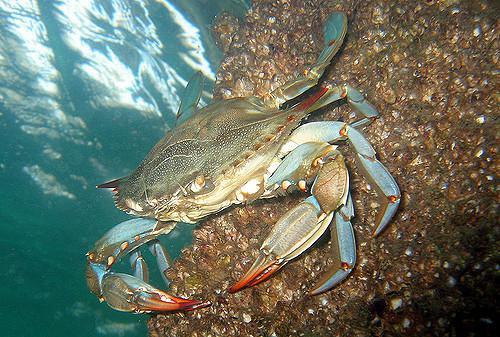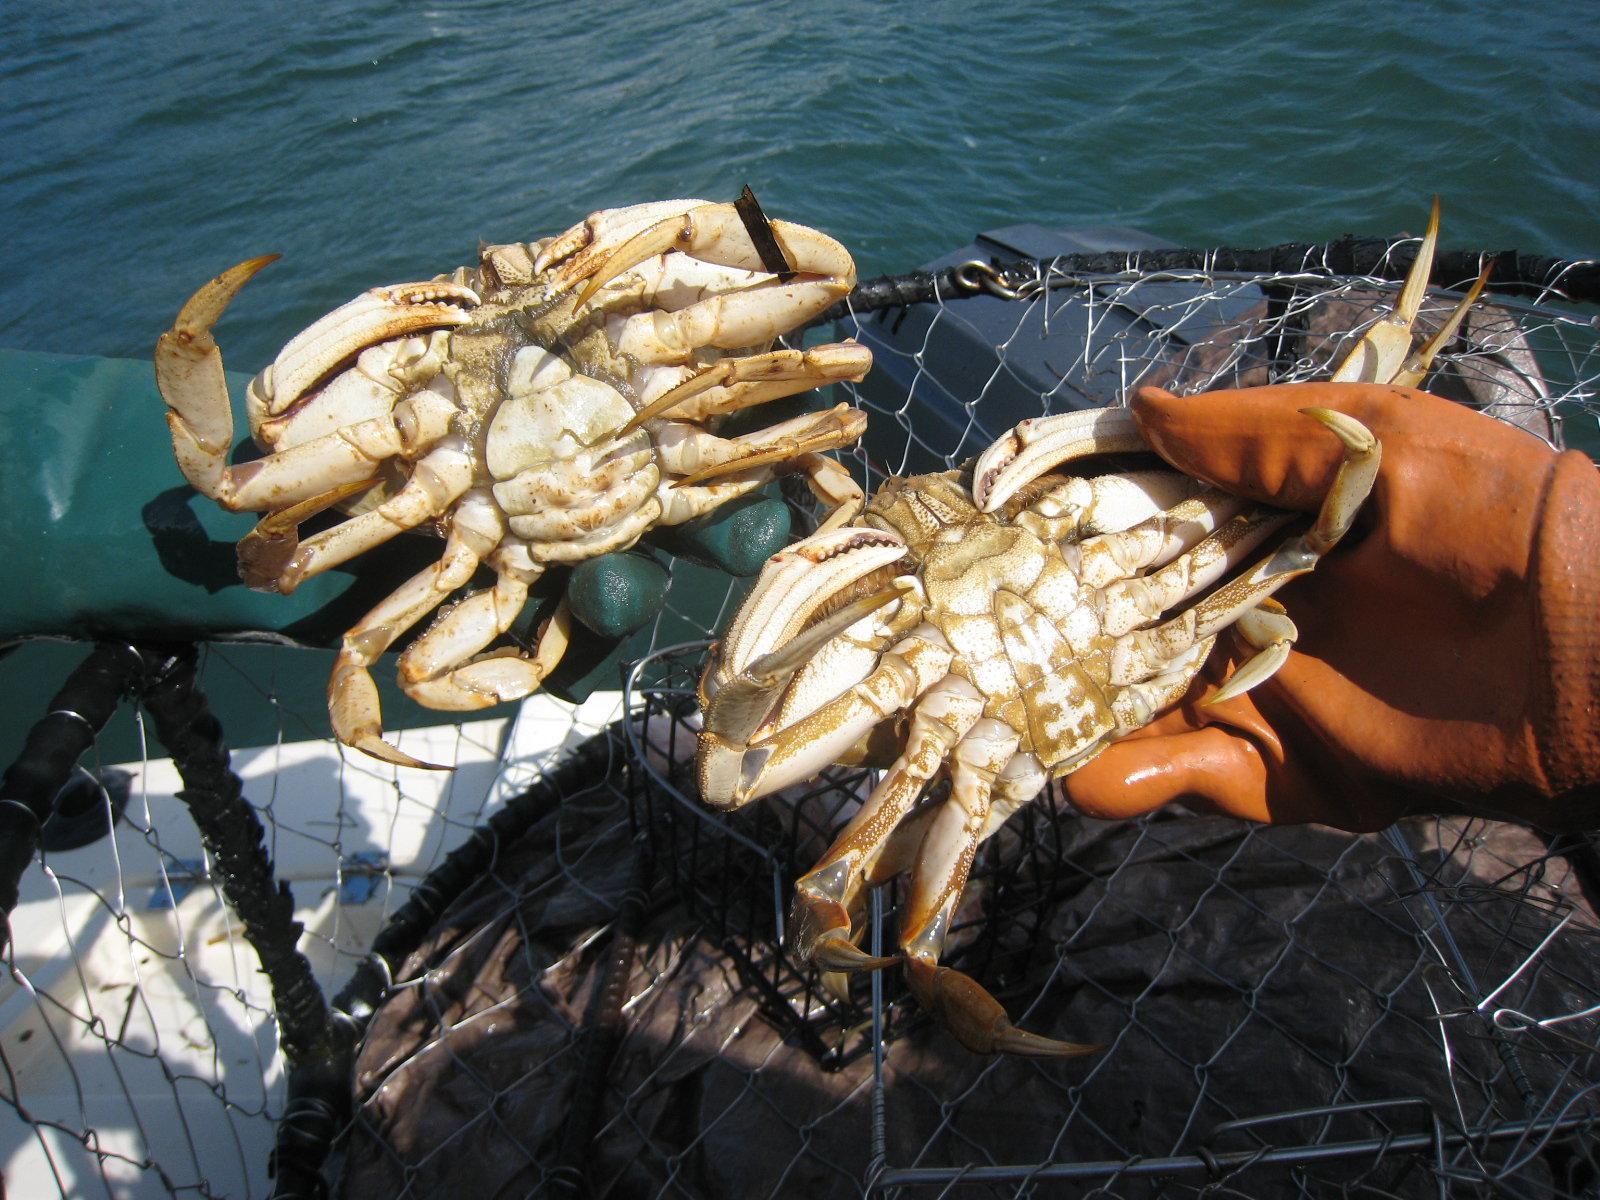The first image is the image on the left, the second image is the image on the right. Analyze the images presented: Is the assertion "Some of the crabs are in a net." valid? Answer yes or no. Yes. The first image is the image on the left, the second image is the image on the right. Considering the images on both sides, is "At least part of an ungloved hand is seen in the left image." valid? Answer yes or no. No. 